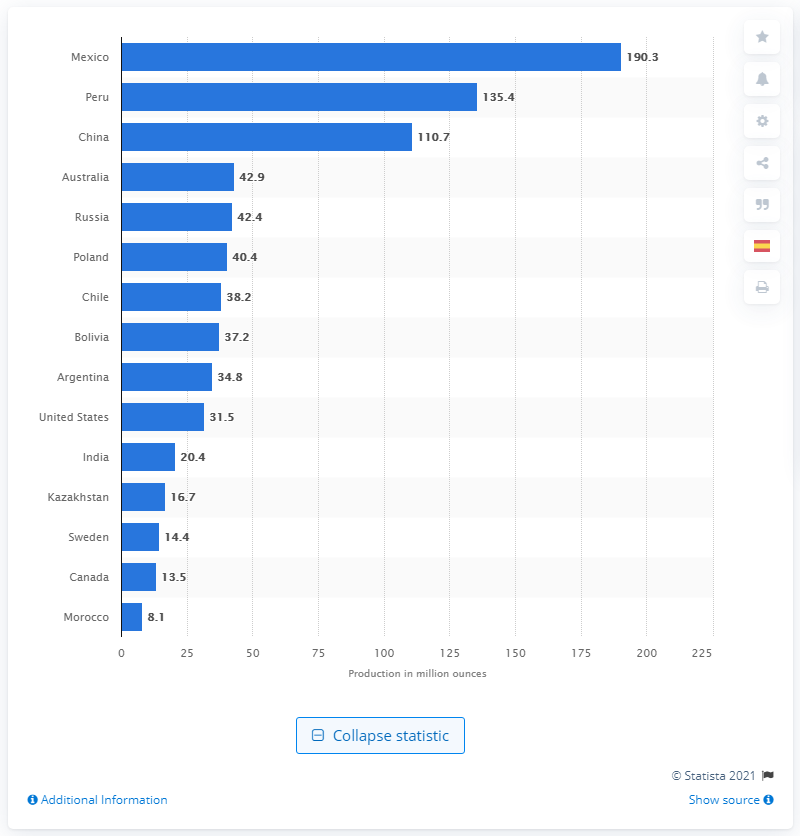Give some essential details in this illustration. Peru was the second largest silver producer in 2019. In 2019, Mexico was the largest silver-producing country in the world, according to records. In 2019, Mexico produced 190.3 million ounces of silver. 